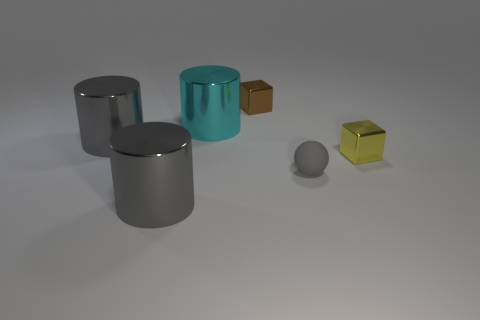Subtract all large cyan shiny cylinders. How many cylinders are left? 2 Add 2 yellow shiny things. How many objects exist? 8 Subtract all gray cylinders. How many cylinders are left? 1 Subtract 2 cylinders. How many cylinders are left? 1 Subtract 0 blue cylinders. How many objects are left? 6 Subtract all spheres. How many objects are left? 5 Subtract all green balls. Subtract all gray cubes. How many balls are left? 1 Subtract all gray blocks. How many gray cylinders are left? 2 Subtract all gray metal objects. Subtract all metallic cubes. How many objects are left? 2 Add 3 large cyan cylinders. How many large cyan cylinders are left? 4 